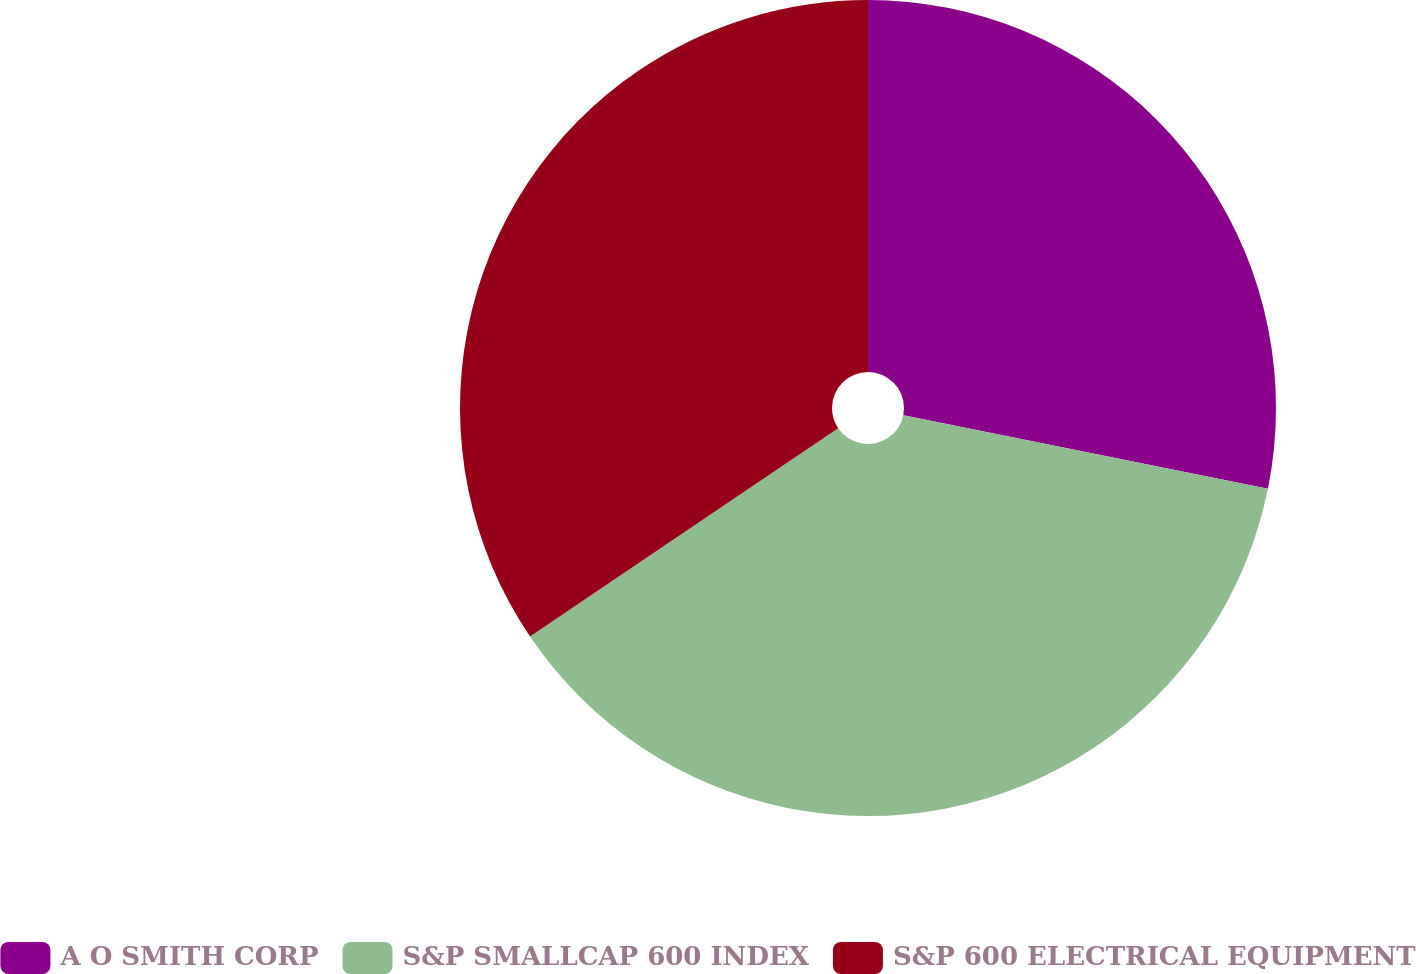Convert chart to OTSL. <chart><loc_0><loc_0><loc_500><loc_500><pie_chart><fcel>A O SMITH CORP<fcel>S&P SMALLCAP 600 INDEX<fcel>S&P 600 ELECTRICAL EQUIPMENT<nl><fcel>28.17%<fcel>37.36%<fcel>34.46%<nl></chart> 